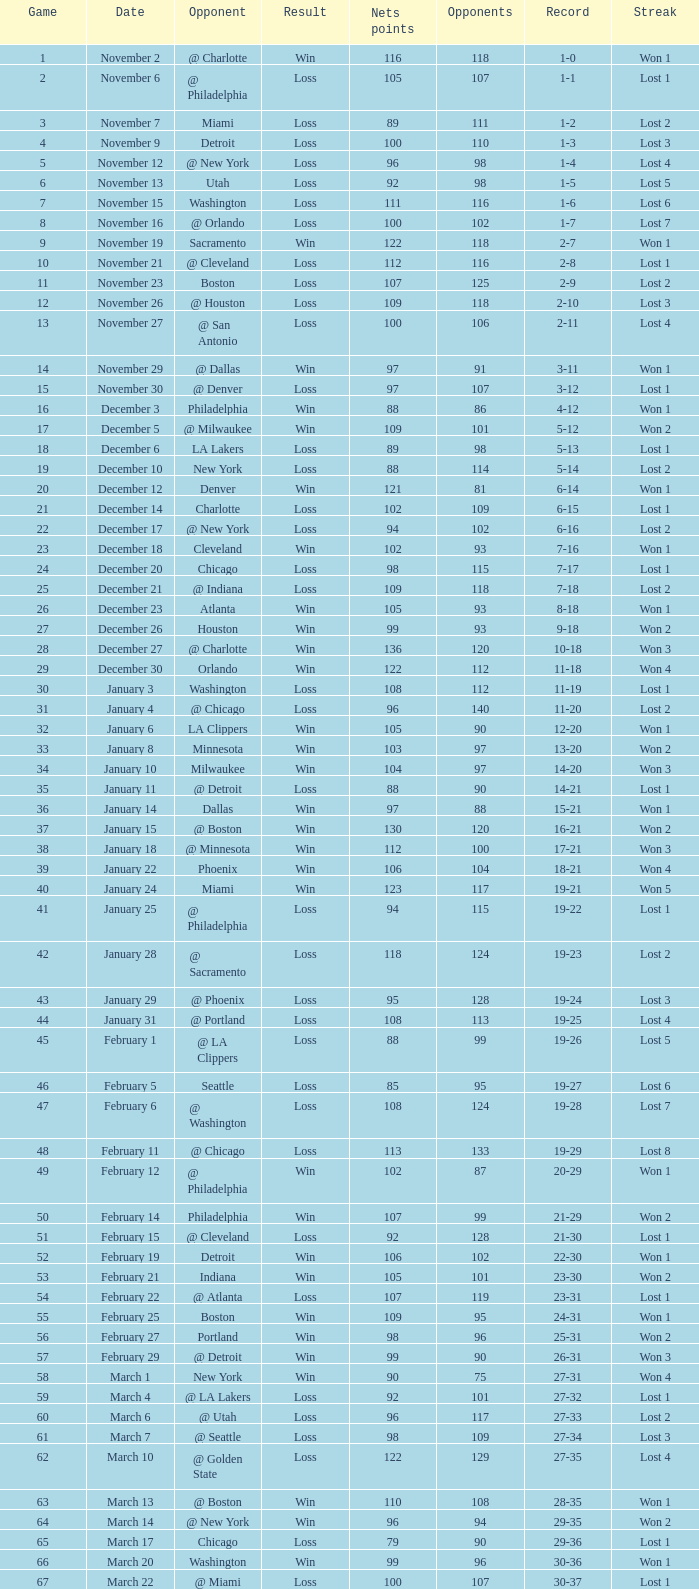How many games had fewer than 118 opponents and more than 109 net points with an opponent of Washington? 1.0. 